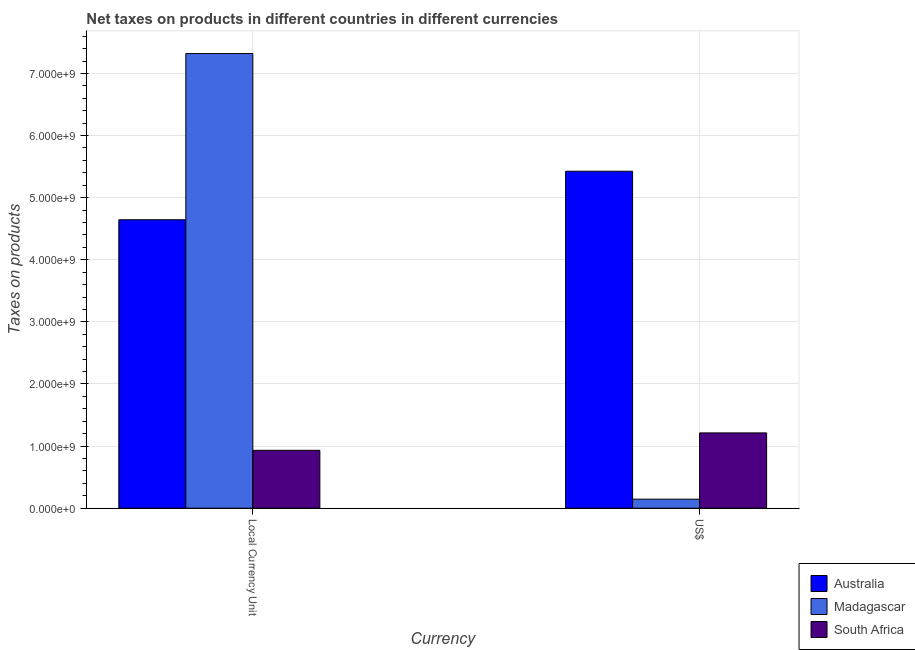How many different coloured bars are there?
Your response must be concise. 3. Are the number of bars per tick equal to the number of legend labels?
Keep it short and to the point. Yes. Are the number of bars on each tick of the X-axis equal?
Make the answer very short. Yes. How many bars are there on the 2nd tick from the right?
Your answer should be very brief. 3. What is the label of the 2nd group of bars from the left?
Give a very brief answer. US$. What is the net taxes in us$ in Madagascar?
Ensure brevity in your answer.  1.45e+08. Across all countries, what is the maximum net taxes in constant 2005 us$?
Offer a very short reply. 7.32e+09. Across all countries, what is the minimum net taxes in constant 2005 us$?
Provide a succinct answer. 9.32e+08. In which country was the net taxes in us$ maximum?
Ensure brevity in your answer.  Australia. In which country was the net taxes in constant 2005 us$ minimum?
Ensure brevity in your answer.  South Africa. What is the total net taxes in us$ in the graph?
Make the answer very short. 6.78e+09. What is the difference between the net taxes in constant 2005 us$ in Australia and that in South Africa?
Ensure brevity in your answer.  3.71e+09. What is the difference between the net taxes in us$ in Madagascar and the net taxes in constant 2005 us$ in South Africa?
Offer a very short reply. -7.87e+08. What is the average net taxes in constant 2005 us$ per country?
Make the answer very short. 4.30e+09. What is the difference between the net taxes in constant 2005 us$ and net taxes in us$ in Australia?
Provide a succinct answer. -7.81e+08. What is the ratio of the net taxes in constant 2005 us$ in South Africa to that in Australia?
Provide a succinct answer. 0.2. Is the net taxes in constant 2005 us$ in Madagascar less than that in Australia?
Keep it short and to the point. No. What does the 2nd bar from the left in US$ represents?
Provide a succinct answer. Madagascar. What does the 1st bar from the right in US$ represents?
Your answer should be compact. South Africa. How many bars are there?
Ensure brevity in your answer.  6. How many countries are there in the graph?
Your response must be concise. 3. What is the difference between two consecutive major ticks on the Y-axis?
Your answer should be very brief. 1.00e+09. Are the values on the major ticks of Y-axis written in scientific E-notation?
Give a very brief answer. Yes. Does the graph contain grids?
Provide a succinct answer. Yes. Where does the legend appear in the graph?
Make the answer very short. Bottom right. How many legend labels are there?
Your response must be concise. 3. How are the legend labels stacked?
Your answer should be very brief. Vertical. What is the title of the graph?
Offer a very short reply. Net taxes on products in different countries in different currencies. What is the label or title of the X-axis?
Provide a short and direct response. Currency. What is the label or title of the Y-axis?
Ensure brevity in your answer.  Taxes on products. What is the Taxes on products of Australia in Local Currency Unit?
Your response must be concise. 4.64e+09. What is the Taxes on products of Madagascar in Local Currency Unit?
Your response must be concise. 7.32e+09. What is the Taxes on products in South Africa in Local Currency Unit?
Your answer should be very brief. 9.32e+08. What is the Taxes on products of Australia in US$?
Your response must be concise. 5.43e+09. What is the Taxes on products of Madagascar in US$?
Provide a succinct answer. 1.45e+08. What is the Taxes on products in South Africa in US$?
Give a very brief answer. 1.21e+09. Across all Currency, what is the maximum Taxes on products in Australia?
Your answer should be compact. 5.43e+09. Across all Currency, what is the maximum Taxes on products in Madagascar?
Make the answer very short. 7.32e+09. Across all Currency, what is the maximum Taxes on products of South Africa?
Offer a terse response. 1.21e+09. Across all Currency, what is the minimum Taxes on products in Australia?
Provide a short and direct response. 4.64e+09. Across all Currency, what is the minimum Taxes on products in Madagascar?
Offer a very short reply. 1.45e+08. Across all Currency, what is the minimum Taxes on products of South Africa?
Your response must be concise. 9.32e+08. What is the total Taxes on products of Australia in the graph?
Offer a very short reply. 1.01e+1. What is the total Taxes on products of Madagascar in the graph?
Your answer should be compact. 7.47e+09. What is the total Taxes on products in South Africa in the graph?
Provide a short and direct response. 2.14e+09. What is the difference between the Taxes on products in Australia in Local Currency Unit and that in US$?
Make the answer very short. -7.81e+08. What is the difference between the Taxes on products of Madagascar in Local Currency Unit and that in US$?
Your answer should be very brief. 7.17e+09. What is the difference between the Taxes on products of South Africa in Local Currency Unit and that in US$?
Make the answer very short. -2.80e+08. What is the difference between the Taxes on products in Australia in Local Currency Unit and the Taxes on products in Madagascar in US$?
Keep it short and to the point. 4.50e+09. What is the difference between the Taxes on products in Australia in Local Currency Unit and the Taxes on products in South Africa in US$?
Keep it short and to the point. 3.43e+09. What is the difference between the Taxes on products in Madagascar in Local Currency Unit and the Taxes on products in South Africa in US$?
Your answer should be very brief. 6.11e+09. What is the average Taxes on products in Australia per Currency?
Provide a short and direct response. 5.03e+09. What is the average Taxes on products of Madagascar per Currency?
Your response must be concise. 3.73e+09. What is the average Taxes on products of South Africa per Currency?
Offer a very short reply. 1.07e+09. What is the difference between the Taxes on products of Australia and Taxes on products of Madagascar in Local Currency Unit?
Your answer should be compact. -2.68e+09. What is the difference between the Taxes on products of Australia and Taxes on products of South Africa in Local Currency Unit?
Make the answer very short. 3.71e+09. What is the difference between the Taxes on products in Madagascar and Taxes on products in South Africa in Local Currency Unit?
Ensure brevity in your answer.  6.39e+09. What is the difference between the Taxes on products of Australia and Taxes on products of Madagascar in US$?
Keep it short and to the point. 5.28e+09. What is the difference between the Taxes on products of Australia and Taxes on products of South Africa in US$?
Offer a very short reply. 4.21e+09. What is the difference between the Taxes on products in Madagascar and Taxes on products in South Africa in US$?
Your answer should be very brief. -1.07e+09. What is the ratio of the Taxes on products in Australia in Local Currency Unit to that in US$?
Offer a terse response. 0.86. What is the ratio of the Taxes on products in Madagascar in Local Currency Unit to that in US$?
Your answer should be compact. 50.41. What is the ratio of the Taxes on products of South Africa in Local Currency Unit to that in US$?
Provide a short and direct response. 0.77. What is the difference between the highest and the second highest Taxes on products of Australia?
Your response must be concise. 7.81e+08. What is the difference between the highest and the second highest Taxes on products in Madagascar?
Your response must be concise. 7.17e+09. What is the difference between the highest and the second highest Taxes on products of South Africa?
Make the answer very short. 2.80e+08. What is the difference between the highest and the lowest Taxes on products of Australia?
Offer a terse response. 7.81e+08. What is the difference between the highest and the lowest Taxes on products in Madagascar?
Keep it short and to the point. 7.17e+09. What is the difference between the highest and the lowest Taxes on products of South Africa?
Your response must be concise. 2.80e+08. 